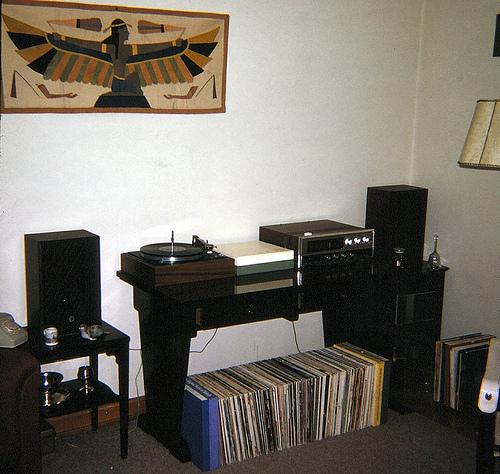Question: how many speakers?
Choices:
A. 3.
B. 4.
C. 2.
D. 5.
Answer with the letter. Answer: C Question: what is under the desk?
Choices:
A. Chair.
B. Records.
C. Book bag.
D. Text book.
Answer with the letter. Answer: B Question: when will they listen to the records?
Choices:
A. Now.
B. After dinner.
C. Tomorrow.
D. Soon.
Answer with the letter. Answer: D Question: why are there so many records?
Choices:
A. Radio station.
B. Collection.
C. Music store.
D. DJ at a party.
Answer with the letter. Answer: B 